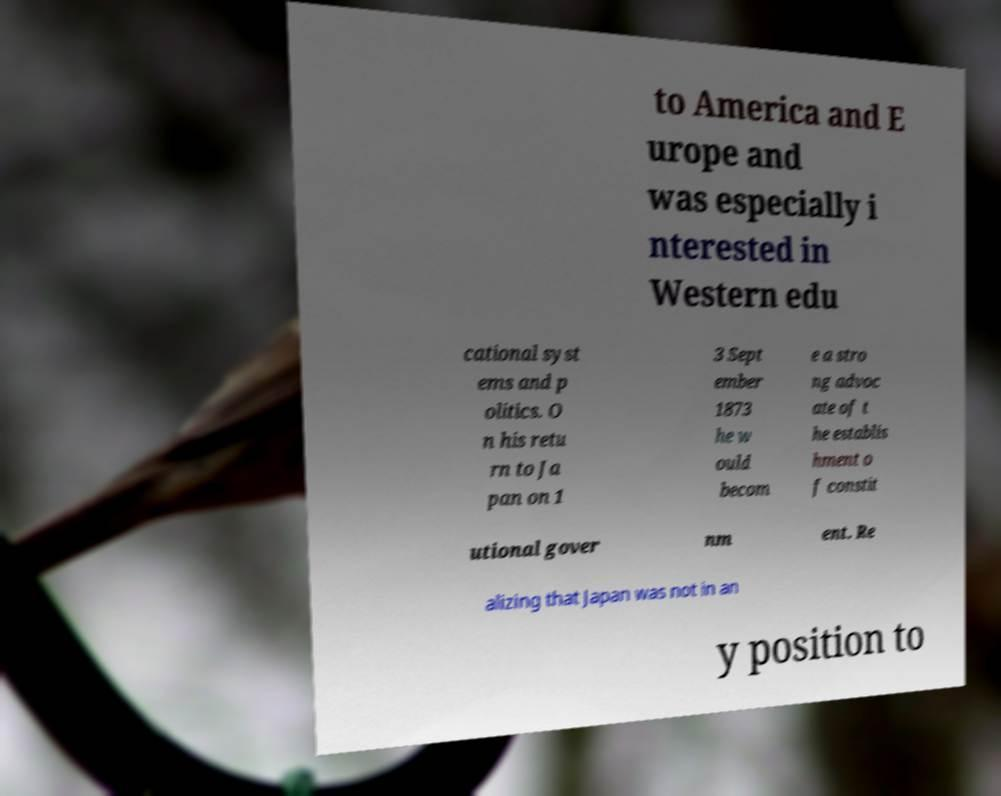Can you read and provide the text displayed in the image?This photo seems to have some interesting text. Can you extract and type it out for me? to America and E urope and was especially i nterested in Western edu cational syst ems and p olitics. O n his retu rn to Ja pan on 1 3 Sept ember 1873 he w ould becom e a stro ng advoc ate of t he establis hment o f constit utional gover nm ent. Re alizing that Japan was not in an y position to 